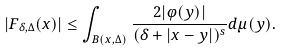Convert formula to latex. <formula><loc_0><loc_0><loc_500><loc_500>| F _ { \delta , \Delta } ( x ) | \leq \int _ { B ( x , \Delta ) } \frac { 2 | \varphi ( y ) | } { ( \delta + | x - y | ) ^ { s } } d \mu ( y ) .</formula> 